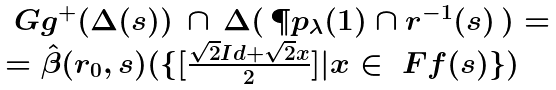Convert formula to latex. <formula><loc_0><loc_0><loc_500><loc_500>\begin{array} { l } \ G g ^ { + } ( \Delta ( s ) ) \, \cap \, \Delta ( \, \P p _ { \lambda } ( 1 ) \cap r ^ { - 1 } ( s ) \, ) = \\ = \hat { \beta } ( r _ { 0 } , s ) ( \{ [ \frac { \sqrt { 2 } I d + \sqrt { 2 } x } { 2 } ] | x \in \ F f ( s ) \} ) \end{array}</formula> 